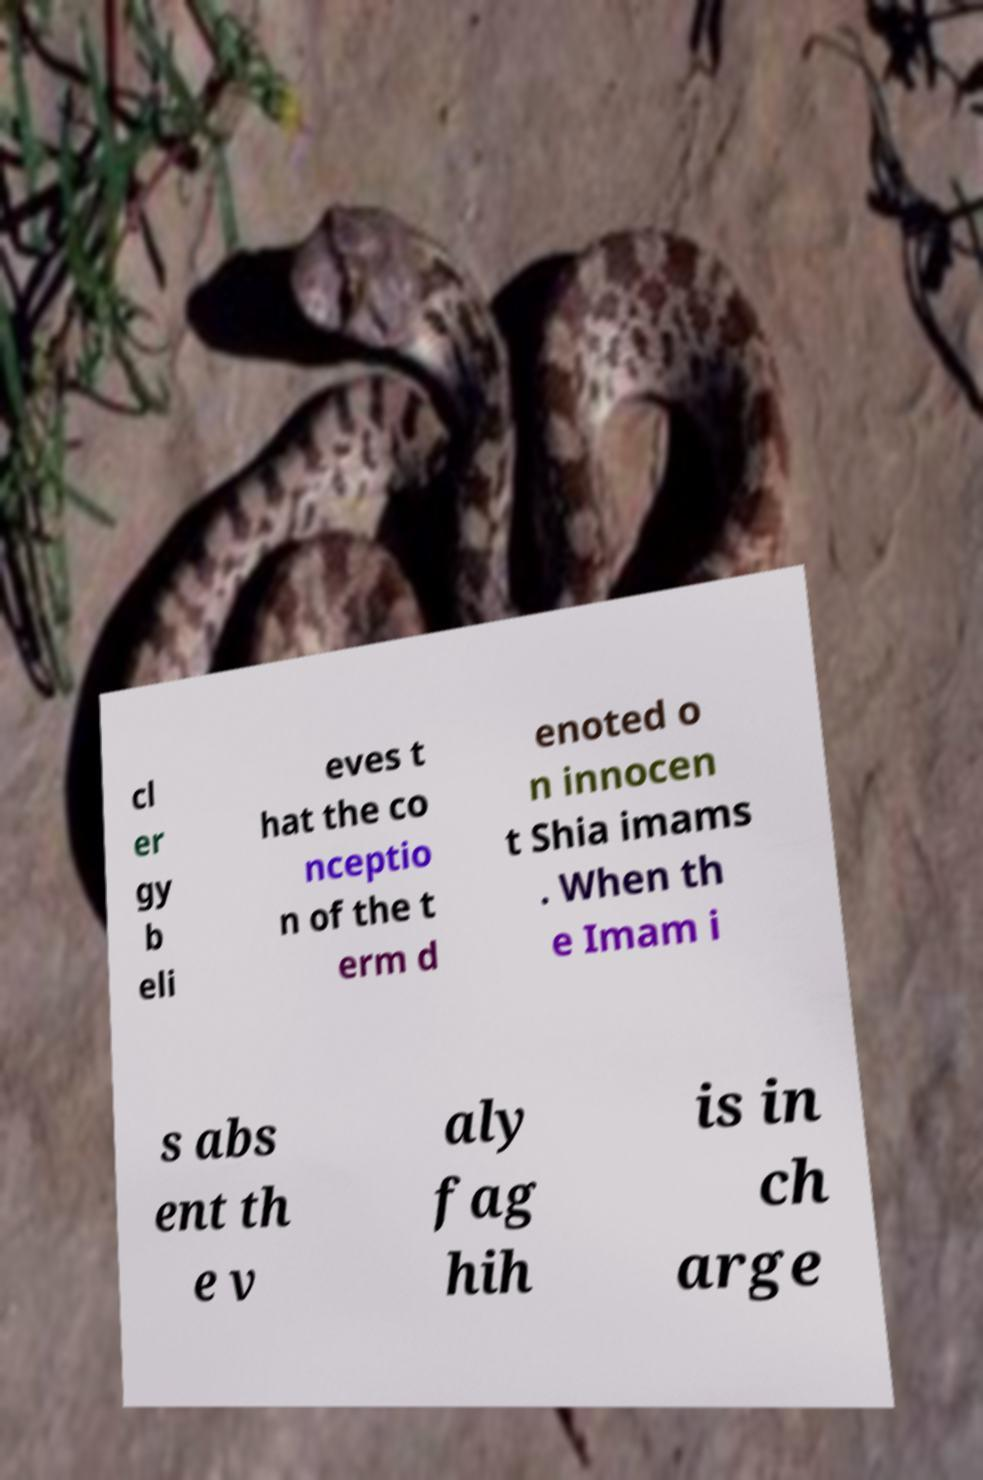There's text embedded in this image that I need extracted. Can you transcribe it verbatim? cl er gy b eli eves t hat the co nceptio n of the t erm d enoted o n innocen t Shia imams . When th e Imam i s abs ent th e v aly fag hih is in ch arge 